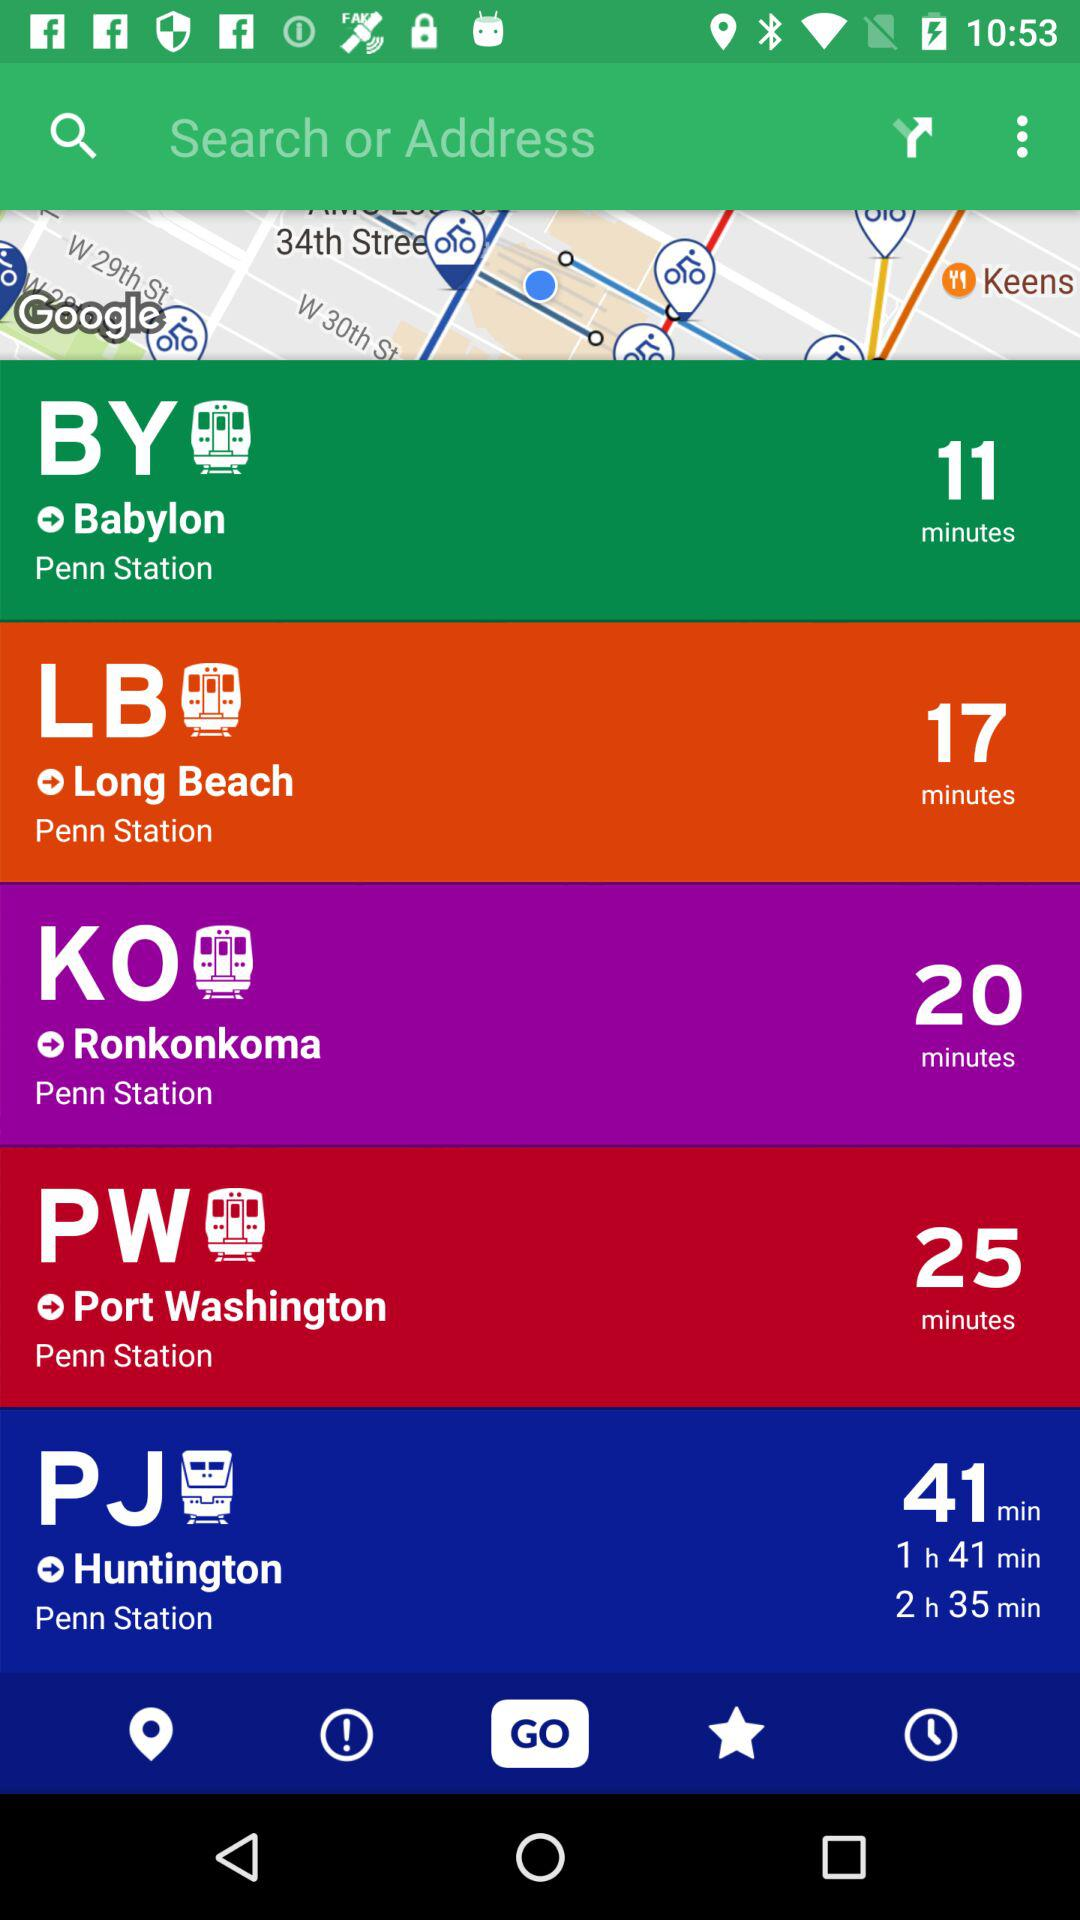From which station does it take 20 minutes to reach "Ronkonkoma"? It takes 20 minutes to reach "Ronkonkoma" from "Penn Station". 